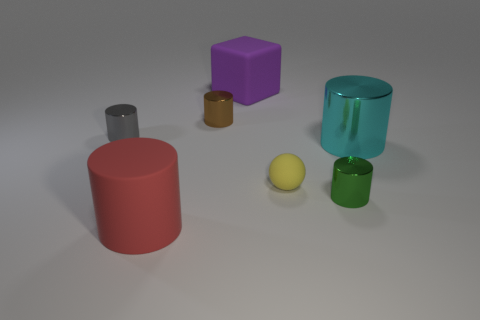There is a shiny cylinder that is on the left side of the large red matte thing; is there a sphere behind it?
Make the answer very short. No. What number of other things are there of the same shape as the tiny yellow matte object?
Offer a very short reply. 0. Is the shape of the big rubber object in front of the large metallic cylinder the same as the matte thing behind the yellow rubber thing?
Your response must be concise. No. What number of big red rubber cylinders are right of the large object right of the tiny metal cylinder that is right of the large rubber cube?
Make the answer very short. 0. What is the color of the matte cylinder?
Ensure brevity in your answer.  Red. What number of other objects are there of the same size as the red matte thing?
Offer a terse response. 2. There is a small gray thing that is the same shape as the brown metallic thing; what is it made of?
Provide a succinct answer. Metal. There is a big cylinder on the left side of the big rubber thing that is right of the large cylinder that is to the left of the small sphere; what is its material?
Offer a very short reply. Rubber. The brown object that is made of the same material as the big cyan object is what size?
Give a very brief answer. Small. Are there any other things that have the same color as the big block?
Offer a very short reply. No. 